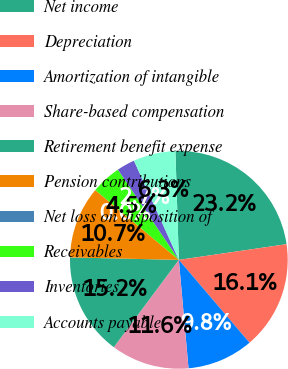Convert chart. <chart><loc_0><loc_0><loc_500><loc_500><pie_chart><fcel>Net income<fcel>Depreciation<fcel>Amortization of intangible<fcel>Share-based compensation<fcel>Retirement benefit expense<fcel>Pension contributions<fcel>Net loss on disposition of<fcel>Receivables<fcel>Inventories<fcel>Accounts payable<nl><fcel>23.2%<fcel>16.06%<fcel>9.82%<fcel>11.6%<fcel>15.17%<fcel>10.71%<fcel>0.01%<fcel>4.47%<fcel>2.69%<fcel>6.26%<nl></chart> 